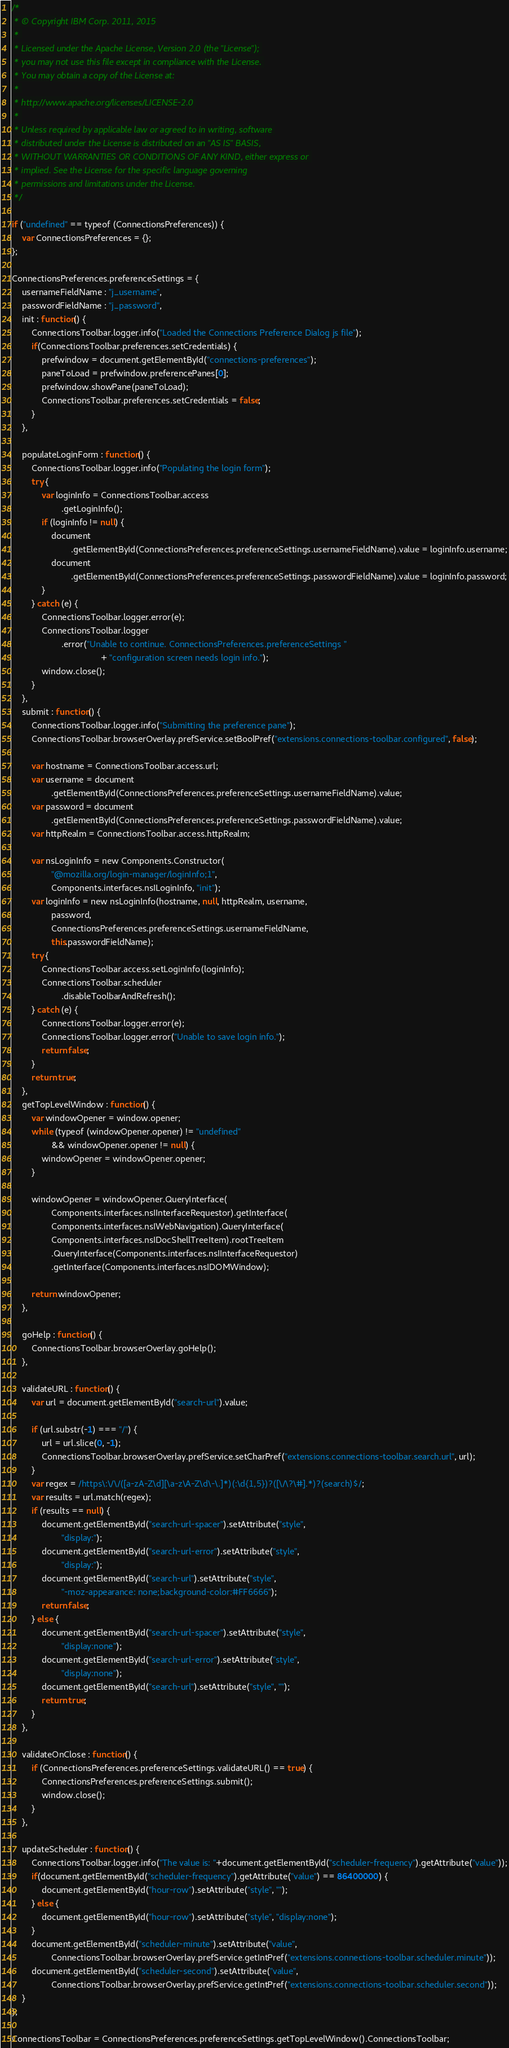<code> <loc_0><loc_0><loc_500><loc_500><_JavaScript_>/*
 * © Copyright IBM Corp. 2011, 2015
 * 
 * Licensed under the Apache License, Version 2.0 (the "License"); 
 * you may not use this file except in compliance with the License. 
 * You may obtain a copy of the License at:
 * 
 * http://www.apache.org/licenses/LICENSE-2.0 
 * 
 * Unless required by applicable law or agreed to in writing, software 
 * distributed under the License is distributed on an "AS IS" BASIS, 
 * WITHOUT WARRANTIES OR CONDITIONS OF ANY KIND, either express or 
 * implied. See the License for the specific language governing 
 * permissions and limitations under the License.
 */

if ("undefined" == typeof (ConnectionsPreferences)) {
    var ConnectionsPreferences = {};
};

ConnectionsPreferences.preferenceSettings = {
    usernameFieldName : "j_username",
    passwordFieldName : "j_password",
    init : function() {
        ConnectionsToolbar.logger.info("Loaded the Connections Preference Dialog js file");
        if(ConnectionsToolbar.preferences.setCredentials) {
            prefwindow = document.getElementById("connections-preferences");
            paneToLoad = prefwindow.preferencePanes[0];
            prefwindow.showPane(paneToLoad);
            ConnectionsToolbar.preferences.setCredentials = false;
        }
    },
    
    populateLoginForm : function() {
        ConnectionsToolbar.logger.info("Populating the login form");
        try {
            var loginInfo = ConnectionsToolbar.access
                    .getLoginInfo();
            if (loginInfo != null) {
                document
                        .getElementById(ConnectionsPreferences.preferenceSettings.usernameFieldName).value = loginInfo.username;
                document
                        .getElementById(ConnectionsPreferences.preferenceSettings.passwordFieldName).value = loginInfo.password;
            }
        } catch (e) {
            ConnectionsToolbar.logger.error(e);
            ConnectionsToolbar.logger
                    .error("Unable to continue. ConnectionsPreferences.preferenceSettings "
                                    + "configuration screen needs login info.");
            window.close();
        }
    },
    submit : function() {
        ConnectionsToolbar.logger.info("Submitting the preference pane");
        ConnectionsToolbar.browserOverlay.prefService.setBoolPref("extensions.connections-toolbar.configured", false);

        var hostname = ConnectionsToolbar.access.url;
        var username = document
                .getElementById(ConnectionsPreferences.preferenceSettings.usernameFieldName).value;
        var password = document
                .getElementById(ConnectionsPreferences.preferenceSettings.passwordFieldName).value;
        var httpRealm = ConnectionsToolbar.access.httpRealm;

        var nsLoginInfo = new Components.Constructor(
                "@mozilla.org/login-manager/loginInfo;1",
                Components.interfaces.nsILoginInfo, "init");
        var loginInfo = new nsLoginInfo(hostname, null, httpRealm, username,
                password,
                ConnectionsPreferences.preferenceSettings.usernameFieldName,
                this.passwordFieldName);
        try {
            ConnectionsToolbar.access.setLoginInfo(loginInfo);
            ConnectionsToolbar.scheduler
                    .disableToolbarAndRefresh();
        } catch (e) {
            ConnectionsToolbar.logger.error(e);
            ConnectionsToolbar.logger.error("Unable to save login info.");
            return false;
        }
        return true;
    },
    getTopLevelWindow : function() {
        var windowOpener = window.opener;
        while (typeof (windowOpener.opener) != "undefined"
                && windowOpener.opener != null) {
            windowOpener = windowOpener.opener;
        }

        windowOpener = windowOpener.QueryInterface(
                Components.interfaces.nsIInterfaceRequestor).getInterface(
                Components.interfaces.nsIWebNavigation).QueryInterface(
                Components.interfaces.nsIDocShellTreeItem).rootTreeItem
                .QueryInterface(Components.interfaces.nsIInterfaceRequestor)
                .getInterface(Components.interfaces.nsIDOMWindow);

        return windowOpener;
    },

    goHelp : function() {
        ConnectionsToolbar.browserOverlay.goHelp();
    },

    validateURL : function() {
        var url = document.getElementById("search-url").value;

        if (url.substr(-1) === "/") {
            url = url.slice(0, -1);
            ConnectionsToolbar.browserOverlay.prefService.setCharPref("extensions.connections-toolbar.search.url", url);
        }
        var regex = /https\:\/\/([a-zA-Z\d][\a-z\A-Z\d\-\.]*)(:\d{1,5})?([\/\?\#].*)?(search)$/;
        var results = url.match(regex);
        if (results == null) {
            document.getElementById("search-url-spacer").setAttribute("style",
                    "display:");
            document.getElementById("search-url-error").setAttribute("style",
                    "display:");
            document.getElementById("search-url").setAttribute("style",
                    "-moz-appearance: none;background-color:#FF6666");
            return false;
        } else {
            document.getElementById("search-url-spacer").setAttribute("style",
                    "display:none");
            document.getElementById("search-url-error").setAttribute("style",
                    "display:none");
            document.getElementById("search-url").setAttribute("style", "");
            return true;
        }
    },

    validateOnClose : function() {
        if (ConnectionsPreferences.preferenceSettings.validateURL() == true) {
            ConnectionsPreferences.preferenceSettings.submit();
            window.close();
        }
    },

    updateScheduler : function() {
        ConnectionsToolbar.logger.info("The value is: "+document.getElementById("scheduler-frequency").getAttribute("value"));
        if(document.getElementById("scheduler-frequency").getAttribute("value") == 86400000) {
            document.getElementById("hour-row").setAttribute("style", "");
        } else {
            document.getElementById("hour-row").setAttribute("style", "display:none");
        }
        document.getElementById("scheduler-minute").setAttribute("value", 
        		ConnectionsToolbar.browserOverlay.prefService.getIntPref("extensions.connections-toolbar.scheduler.minute"));
        document.getElementById("scheduler-second").setAttribute("value",
        		ConnectionsToolbar.browserOverlay.prefService.getIntPref("extensions.connections-toolbar.scheduler.second"));
    }
};

ConnectionsToolbar = ConnectionsPreferences.preferenceSettings.getTopLevelWindow().ConnectionsToolbar;</code> 